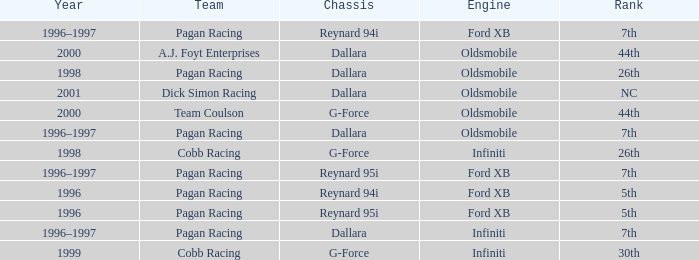What rank did the dallara chassis finish in 2000? 44th. 